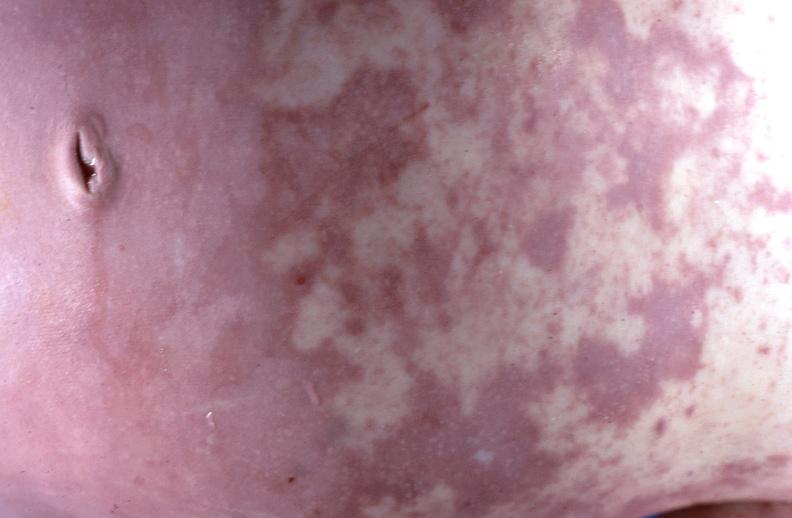does this image show gram negative septicemia due to scalp electrode in a neonate?
Answer the question using a single word or phrase. Yes 